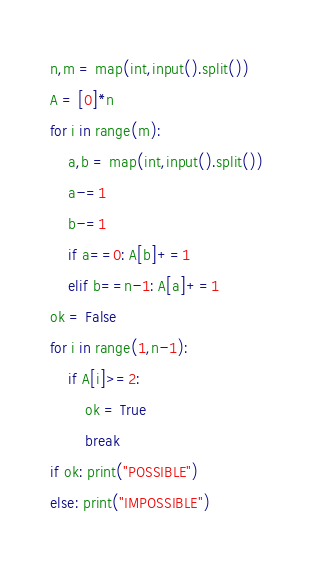<code> <loc_0><loc_0><loc_500><loc_500><_Python_>n,m = map(int,input().split())
A = [0]*n
for i in range(m):
    a,b = map(int,input().split())
    a-=1
    b-=1
    if a==0: A[b]+=1
    elif b==n-1: A[a]+=1
ok = False
for i in range(1,n-1):
    if A[i]>=2:
        ok = True
        break
if ok: print("POSSIBLE")
else: print("IMPOSSIBLE")</code> 